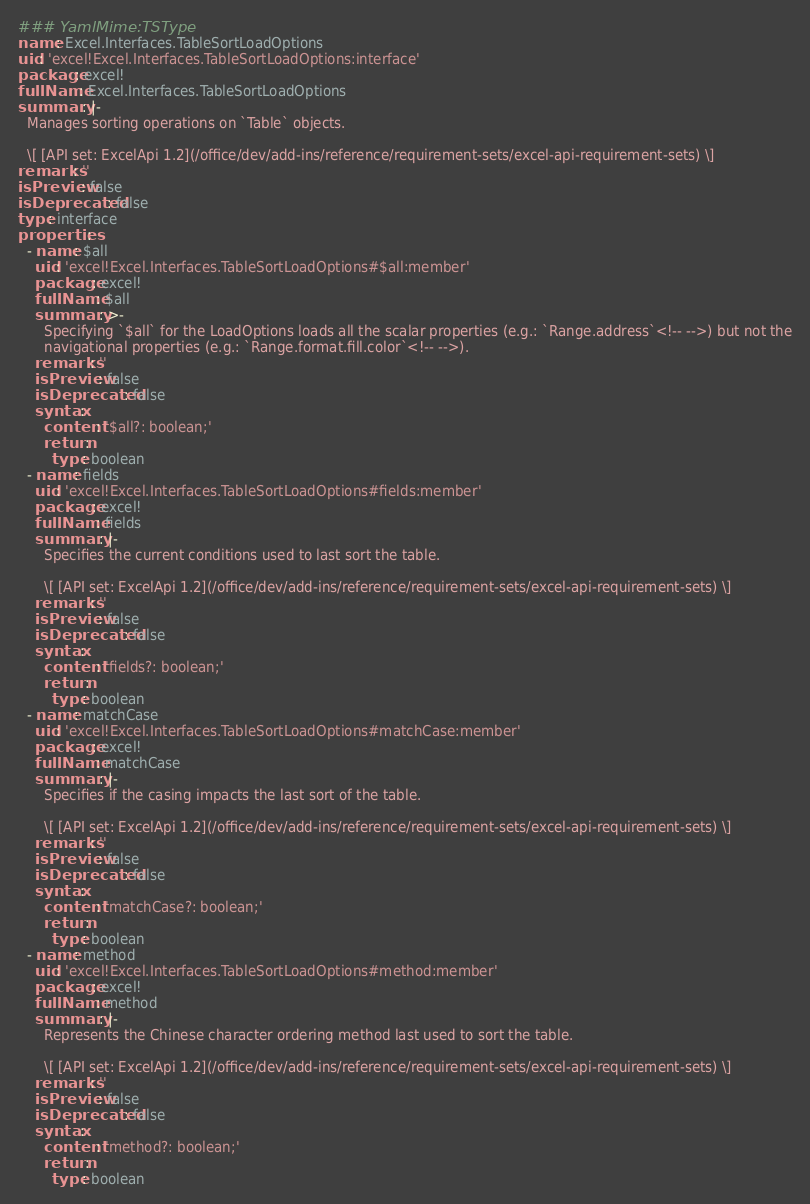<code> <loc_0><loc_0><loc_500><loc_500><_YAML_>### YamlMime:TSType
name: Excel.Interfaces.TableSortLoadOptions
uid: 'excel!Excel.Interfaces.TableSortLoadOptions:interface'
package: excel!
fullName: Excel.Interfaces.TableSortLoadOptions
summary: |-
  Manages sorting operations on `Table` objects.

  \[ [API set: ExcelApi 1.2](/office/dev/add-ins/reference/requirement-sets/excel-api-requirement-sets) \]
remarks: ''
isPreview: false
isDeprecated: false
type: interface
properties:
  - name: $all
    uid: 'excel!Excel.Interfaces.TableSortLoadOptions#$all:member'
    package: excel!
    fullName: $all
    summary: >-
      Specifying `$all` for the LoadOptions loads all the scalar properties (e.g.: `Range.address`<!-- -->) but not the
      navigational properties (e.g.: `Range.format.fill.color`<!-- -->).
    remarks: ''
    isPreview: false
    isDeprecated: false
    syntax:
      content: '$all?: boolean;'
      return:
        type: boolean
  - name: fields
    uid: 'excel!Excel.Interfaces.TableSortLoadOptions#fields:member'
    package: excel!
    fullName: fields
    summary: |-
      Specifies the current conditions used to last sort the table.

      \[ [API set: ExcelApi 1.2](/office/dev/add-ins/reference/requirement-sets/excel-api-requirement-sets) \]
    remarks: ''
    isPreview: false
    isDeprecated: false
    syntax:
      content: 'fields?: boolean;'
      return:
        type: boolean
  - name: matchCase
    uid: 'excel!Excel.Interfaces.TableSortLoadOptions#matchCase:member'
    package: excel!
    fullName: matchCase
    summary: |-
      Specifies if the casing impacts the last sort of the table.

      \[ [API set: ExcelApi 1.2](/office/dev/add-ins/reference/requirement-sets/excel-api-requirement-sets) \]
    remarks: ''
    isPreview: false
    isDeprecated: false
    syntax:
      content: 'matchCase?: boolean;'
      return:
        type: boolean
  - name: method
    uid: 'excel!Excel.Interfaces.TableSortLoadOptions#method:member'
    package: excel!
    fullName: method
    summary: |-
      Represents the Chinese character ordering method last used to sort the table.

      \[ [API set: ExcelApi 1.2](/office/dev/add-ins/reference/requirement-sets/excel-api-requirement-sets) \]
    remarks: ''
    isPreview: false
    isDeprecated: false
    syntax:
      content: 'method?: boolean;'
      return:
        type: boolean
</code> 